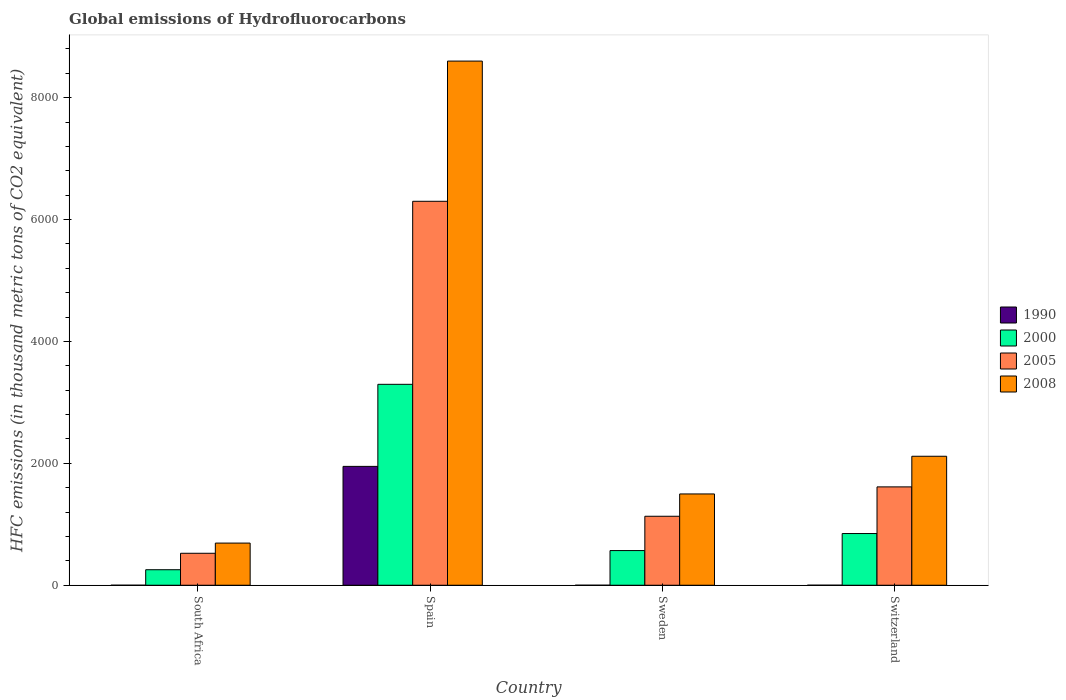Are the number of bars per tick equal to the number of legend labels?
Give a very brief answer. Yes. Are the number of bars on each tick of the X-axis equal?
Your answer should be compact. Yes. How many bars are there on the 1st tick from the left?
Your response must be concise. 4. How many bars are there on the 2nd tick from the right?
Provide a succinct answer. 4. What is the global emissions of Hydrofluorocarbons in 2008 in Sweden?
Give a very brief answer. 1498. Across all countries, what is the maximum global emissions of Hydrofluorocarbons in 1990?
Offer a terse response. 1950.3. Across all countries, what is the minimum global emissions of Hydrofluorocarbons in 2008?
Give a very brief answer. 691.6. In which country was the global emissions of Hydrofluorocarbons in 1990 minimum?
Provide a short and direct response. South Africa. What is the total global emissions of Hydrofluorocarbons in 2005 in the graph?
Offer a terse response. 9570.5. What is the difference between the global emissions of Hydrofluorocarbons in 2000 in South Africa and that in Spain?
Give a very brief answer. -3042.2. What is the difference between the global emissions of Hydrofluorocarbons in 1990 in South Africa and the global emissions of Hydrofluorocarbons in 2000 in Switzerland?
Offer a terse response. -848. What is the average global emissions of Hydrofluorocarbons in 2000 per country?
Offer a very short reply. 1242.1. What is the difference between the global emissions of Hydrofluorocarbons of/in 1990 and global emissions of Hydrofluorocarbons of/in 2008 in Switzerland?
Offer a terse response. -2116.1. What is the ratio of the global emissions of Hydrofluorocarbons in 2008 in South Africa to that in Spain?
Keep it short and to the point. 0.08. Is the global emissions of Hydrofluorocarbons in 1990 in South Africa less than that in Switzerland?
Your answer should be very brief. Yes. Is the difference between the global emissions of Hydrofluorocarbons in 1990 in South Africa and Switzerland greater than the difference between the global emissions of Hydrofluorocarbons in 2008 in South Africa and Switzerland?
Keep it short and to the point. Yes. What is the difference between the highest and the second highest global emissions of Hydrofluorocarbons in 2008?
Keep it short and to the point. 7102.9. What is the difference between the highest and the lowest global emissions of Hydrofluorocarbons in 2008?
Ensure brevity in your answer.  7909.3. What does the 3rd bar from the left in Switzerland represents?
Give a very brief answer. 2005. How many bars are there?
Ensure brevity in your answer.  16. How many countries are there in the graph?
Ensure brevity in your answer.  4. Are the values on the major ticks of Y-axis written in scientific E-notation?
Ensure brevity in your answer.  No. Where does the legend appear in the graph?
Make the answer very short. Center right. What is the title of the graph?
Make the answer very short. Global emissions of Hydrofluorocarbons. Does "1995" appear as one of the legend labels in the graph?
Make the answer very short. No. What is the label or title of the X-axis?
Keep it short and to the point. Country. What is the label or title of the Y-axis?
Your response must be concise. HFC emissions (in thousand metric tons of CO2 equivalent). What is the HFC emissions (in thousand metric tons of CO2 equivalent) of 2000 in South Africa?
Ensure brevity in your answer.  254.6. What is the HFC emissions (in thousand metric tons of CO2 equivalent) of 2005 in South Africa?
Your answer should be compact. 524.5. What is the HFC emissions (in thousand metric tons of CO2 equivalent) of 2008 in South Africa?
Your response must be concise. 691.6. What is the HFC emissions (in thousand metric tons of CO2 equivalent) in 1990 in Spain?
Your answer should be compact. 1950.3. What is the HFC emissions (in thousand metric tons of CO2 equivalent) in 2000 in Spain?
Your response must be concise. 3296.8. What is the HFC emissions (in thousand metric tons of CO2 equivalent) of 2005 in Spain?
Offer a terse response. 6300.3. What is the HFC emissions (in thousand metric tons of CO2 equivalent) in 2008 in Spain?
Make the answer very short. 8600.9. What is the HFC emissions (in thousand metric tons of CO2 equivalent) of 2000 in Sweden?
Ensure brevity in your answer.  568.8. What is the HFC emissions (in thousand metric tons of CO2 equivalent) of 2005 in Sweden?
Make the answer very short. 1131.9. What is the HFC emissions (in thousand metric tons of CO2 equivalent) in 2008 in Sweden?
Give a very brief answer. 1498. What is the HFC emissions (in thousand metric tons of CO2 equivalent) in 1990 in Switzerland?
Offer a very short reply. 0.3. What is the HFC emissions (in thousand metric tons of CO2 equivalent) in 2000 in Switzerland?
Provide a succinct answer. 848.2. What is the HFC emissions (in thousand metric tons of CO2 equivalent) in 2005 in Switzerland?
Provide a short and direct response. 1613.8. What is the HFC emissions (in thousand metric tons of CO2 equivalent) of 2008 in Switzerland?
Your answer should be compact. 2116.4. Across all countries, what is the maximum HFC emissions (in thousand metric tons of CO2 equivalent) in 1990?
Keep it short and to the point. 1950.3. Across all countries, what is the maximum HFC emissions (in thousand metric tons of CO2 equivalent) of 2000?
Offer a terse response. 3296.8. Across all countries, what is the maximum HFC emissions (in thousand metric tons of CO2 equivalent) in 2005?
Your response must be concise. 6300.3. Across all countries, what is the maximum HFC emissions (in thousand metric tons of CO2 equivalent) of 2008?
Your answer should be compact. 8600.9. Across all countries, what is the minimum HFC emissions (in thousand metric tons of CO2 equivalent) of 1990?
Your answer should be very brief. 0.2. Across all countries, what is the minimum HFC emissions (in thousand metric tons of CO2 equivalent) of 2000?
Make the answer very short. 254.6. Across all countries, what is the minimum HFC emissions (in thousand metric tons of CO2 equivalent) of 2005?
Keep it short and to the point. 524.5. Across all countries, what is the minimum HFC emissions (in thousand metric tons of CO2 equivalent) of 2008?
Your answer should be very brief. 691.6. What is the total HFC emissions (in thousand metric tons of CO2 equivalent) in 1990 in the graph?
Make the answer very short. 1951. What is the total HFC emissions (in thousand metric tons of CO2 equivalent) of 2000 in the graph?
Your response must be concise. 4968.4. What is the total HFC emissions (in thousand metric tons of CO2 equivalent) in 2005 in the graph?
Your answer should be compact. 9570.5. What is the total HFC emissions (in thousand metric tons of CO2 equivalent) in 2008 in the graph?
Your answer should be compact. 1.29e+04. What is the difference between the HFC emissions (in thousand metric tons of CO2 equivalent) in 1990 in South Africa and that in Spain?
Offer a terse response. -1950.1. What is the difference between the HFC emissions (in thousand metric tons of CO2 equivalent) of 2000 in South Africa and that in Spain?
Ensure brevity in your answer.  -3042.2. What is the difference between the HFC emissions (in thousand metric tons of CO2 equivalent) of 2005 in South Africa and that in Spain?
Your response must be concise. -5775.8. What is the difference between the HFC emissions (in thousand metric tons of CO2 equivalent) in 2008 in South Africa and that in Spain?
Your answer should be very brief. -7909.3. What is the difference between the HFC emissions (in thousand metric tons of CO2 equivalent) in 1990 in South Africa and that in Sweden?
Your response must be concise. 0. What is the difference between the HFC emissions (in thousand metric tons of CO2 equivalent) of 2000 in South Africa and that in Sweden?
Provide a short and direct response. -314.2. What is the difference between the HFC emissions (in thousand metric tons of CO2 equivalent) of 2005 in South Africa and that in Sweden?
Offer a terse response. -607.4. What is the difference between the HFC emissions (in thousand metric tons of CO2 equivalent) in 2008 in South Africa and that in Sweden?
Your answer should be compact. -806.4. What is the difference between the HFC emissions (in thousand metric tons of CO2 equivalent) in 2000 in South Africa and that in Switzerland?
Your response must be concise. -593.6. What is the difference between the HFC emissions (in thousand metric tons of CO2 equivalent) of 2005 in South Africa and that in Switzerland?
Provide a succinct answer. -1089.3. What is the difference between the HFC emissions (in thousand metric tons of CO2 equivalent) in 2008 in South Africa and that in Switzerland?
Your answer should be very brief. -1424.8. What is the difference between the HFC emissions (in thousand metric tons of CO2 equivalent) of 1990 in Spain and that in Sweden?
Make the answer very short. 1950.1. What is the difference between the HFC emissions (in thousand metric tons of CO2 equivalent) in 2000 in Spain and that in Sweden?
Offer a terse response. 2728. What is the difference between the HFC emissions (in thousand metric tons of CO2 equivalent) of 2005 in Spain and that in Sweden?
Give a very brief answer. 5168.4. What is the difference between the HFC emissions (in thousand metric tons of CO2 equivalent) of 2008 in Spain and that in Sweden?
Provide a succinct answer. 7102.9. What is the difference between the HFC emissions (in thousand metric tons of CO2 equivalent) in 1990 in Spain and that in Switzerland?
Make the answer very short. 1950. What is the difference between the HFC emissions (in thousand metric tons of CO2 equivalent) in 2000 in Spain and that in Switzerland?
Your answer should be very brief. 2448.6. What is the difference between the HFC emissions (in thousand metric tons of CO2 equivalent) of 2005 in Spain and that in Switzerland?
Provide a succinct answer. 4686.5. What is the difference between the HFC emissions (in thousand metric tons of CO2 equivalent) in 2008 in Spain and that in Switzerland?
Your answer should be very brief. 6484.5. What is the difference between the HFC emissions (in thousand metric tons of CO2 equivalent) of 2000 in Sweden and that in Switzerland?
Make the answer very short. -279.4. What is the difference between the HFC emissions (in thousand metric tons of CO2 equivalent) in 2005 in Sweden and that in Switzerland?
Provide a succinct answer. -481.9. What is the difference between the HFC emissions (in thousand metric tons of CO2 equivalent) of 2008 in Sweden and that in Switzerland?
Keep it short and to the point. -618.4. What is the difference between the HFC emissions (in thousand metric tons of CO2 equivalent) of 1990 in South Africa and the HFC emissions (in thousand metric tons of CO2 equivalent) of 2000 in Spain?
Your answer should be very brief. -3296.6. What is the difference between the HFC emissions (in thousand metric tons of CO2 equivalent) of 1990 in South Africa and the HFC emissions (in thousand metric tons of CO2 equivalent) of 2005 in Spain?
Offer a terse response. -6300.1. What is the difference between the HFC emissions (in thousand metric tons of CO2 equivalent) in 1990 in South Africa and the HFC emissions (in thousand metric tons of CO2 equivalent) in 2008 in Spain?
Your answer should be very brief. -8600.7. What is the difference between the HFC emissions (in thousand metric tons of CO2 equivalent) of 2000 in South Africa and the HFC emissions (in thousand metric tons of CO2 equivalent) of 2005 in Spain?
Your answer should be compact. -6045.7. What is the difference between the HFC emissions (in thousand metric tons of CO2 equivalent) of 2000 in South Africa and the HFC emissions (in thousand metric tons of CO2 equivalent) of 2008 in Spain?
Your answer should be very brief. -8346.3. What is the difference between the HFC emissions (in thousand metric tons of CO2 equivalent) in 2005 in South Africa and the HFC emissions (in thousand metric tons of CO2 equivalent) in 2008 in Spain?
Your answer should be compact. -8076.4. What is the difference between the HFC emissions (in thousand metric tons of CO2 equivalent) of 1990 in South Africa and the HFC emissions (in thousand metric tons of CO2 equivalent) of 2000 in Sweden?
Provide a short and direct response. -568.6. What is the difference between the HFC emissions (in thousand metric tons of CO2 equivalent) of 1990 in South Africa and the HFC emissions (in thousand metric tons of CO2 equivalent) of 2005 in Sweden?
Make the answer very short. -1131.7. What is the difference between the HFC emissions (in thousand metric tons of CO2 equivalent) of 1990 in South Africa and the HFC emissions (in thousand metric tons of CO2 equivalent) of 2008 in Sweden?
Offer a very short reply. -1497.8. What is the difference between the HFC emissions (in thousand metric tons of CO2 equivalent) of 2000 in South Africa and the HFC emissions (in thousand metric tons of CO2 equivalent) of 2005 in Sweden?
Provide a short and direct response. -877.3. What is the difference between the HFC emissions (in thousand metric tons of CO2 equivalent) in 2000 in South Africa and the HFC emissions (in thousand metric tons of CO2 equivalent) in 2008 in Sweden?
Make the answer very short. -1243.4. What is the difference between the HFC emissions (in thousand metric tons of CO2 equivalent) in 2005 in South Africa and the HFC emissions (in thousand metric tons of CO2 equivalent) in 2008 in Sweden?
Make the answer very short. -973.5. What is the difference between the HFC emissions (in thousand metric tons of CO2 equivalent) in 1990 in South Africa and the HFC emissions (in thousand metric tons of CO2 equivalent) in 2000 in Switzerland?
Give a very brief answer. -848. What is the difference between the HFC emissions (in thousand metric tons of CO2 equivalent) of 1990 in South Africa and the HFC emissions (in thousand metric tons of CO2 equivalent) of 2005 in Switzerland?
Your response must be concise. -1613.6. What is the difference between the HFC emissions (in thousand metric tons of CO2 equivalent) of 1990 in South Africa and the HFC emissions (in thousand metric tons of CO2 equivalent) of 2008 in Switzerland?
Provide a short and direct response. -2116.2. What is the difference between the HFC emissions (in thousand metric tons of CO2 equivalent) of 2000 in South Africa and the HFC emissions (in thousand metric tons of CO2 equivalent) of 2005 in Switzerland?
Your answer should be very brief. -1359.2. What is the difference between the HFC emissions (in thousand metric tons of CO2 equivalent) in 2000 in South Africa and the HFC emissions (in thousand metric tons of CO2 equivalent) in 2008 in Switzerland?
Your response must be concise. -1861.8. What is the difference between the HFC emissions (in thousand metric tons of CO2 equivalent) of 2005 in South Africa and the HFC emissions (in thousand metric tons of CO2 equivalent) of 2008 in Switzerland?
Your answer should be compact. -1591.9. What is the difference between the HFC emissions (in thousand metric tons of CO2 equivalent) of 1990 in Spain and the HFC emissions (in thousand metric tons of CO2 equivalent) of 2000 in Sweden?
Keep it short and to the point. 1381.5. What is the difference between the HFC emissions (in thousand metric tons of CO2 equivalent) in 1990 in Spain and the HFC emissions (in thousand metric tons of CO2 equivalent) in 2005 in Sweden?
Provide a succinct answer. 818.4. What is the difference between the HFC emissions (in thousand metric tons of CO2 equivalent) in 1990 in Spain and the HFC emissions (in thousand metric tons of CO2 equivalent) in 2008 in Sweden?
Make the answer very short. 452.3. What is the difference between the HFC emissions (in thousand metric tons of CO2 equivalent) in 2000 in Spain and the HFC emissions (in thousand metric tons of CO2 equivalent) in 2005 in Sweden?
Provide a succinct answer. 2164.9. What is the difference between the HFC emissions (in thousand metric tons of CO2 equivalent) in 2000 in Spain and the HFC emissions (in thousand metric tons of CO2 equivalent) in 2008 in Sweden?
Keep it short and to the point. 1798.8. What is the difference between the HFC emissions (in thousand metric tons of CO2 equivalent) in 2005 in Spain and the HFC emissions (in thousand metric tons of CO2 equivalent) in 2008 in Sweden?
Your answer should be very brief. 4802.3. What is the difference between the HFC emissions (in thousand metric tons of CO2 equivalent) in 1990 in Spain and the HFC emissions (in thousand metric tons of CO2 equivalent) in 2000 in Switzerland?
Offer a very short reply. 1102.1. What is the difference between the HFC emissions (in thousand metric tons of CO2 equivalent) of 1990 in Spain and the HFC emissions (in thousand metric tons of CO2 equivalent) of 2005 in Switzerland?
Your response must be concise. 336.5. What is the difference between the HFC emissions (in thousand metric tons of CO2 equivalent) in 1990 in Spain and the HFC emissions (in thousand metric tons of CO2 equivalent) in 2008 in Switzerland?
Ensure brevity in your answer.  -166.1. What is the difference between the HFC emissions (in thousand metric tons of CO2 equivalent) of 2000 in Spain and the HFC emissions (in thousand metric tons of CO2 equivalent) of 2005 in Switzerland?
Offer a very short reply. 1683. What is the difference between the HFC emissions (in thousand metric tons of CO2 equivalent) in 2000 in Spain and the HFC emissions (in thousand metric tons of CO2 equivalent) in 2008 in Switzerland?
Keep it short and to the point. 1180.4. What is the difference between the HFC emissions (in thousand metric tons of CO2 equivalent) in 2005 in Spain and the HFC emissions (in thousand metric tons of CO2 equivalent) in 2008 in Switzerland?
Keep it short and to the point. 4183.9. What is the difference between the HFC emissions (in thousand metric tons of CO2 equivalent) in 1990 in Sweden and the HFC emissions (in thousand metric tons of CO2 equivalent) in 2000 in Switzerland?
Give a very brief answer. -848. What is the difference between the HFC emissions (in thousand metric tons of CO2 equivalent) in 1990 in Sweden and the HFC emissions (in thousand metric tons of CO2 equivalent) in 2005 in Switzerland?
Offer a terse response. -1613.6. What is the difference between the HFC emissions (in thousand metric tons of CO2 equivalent) of 1990 in Sweden and the HFC emissions (in thousand metric tons of CO2 equivalent) of 2008 in Switzerland?
Your response must be concise. -2116.2. What is the difference between the HFC emissions (in thousand metric tons of CO2 equivalent) in 2000 in Sweden and the HFC emissions (in thousand metric tons of CO2 equivalent) in 2005 in Switzerland?
Make the answer very short. -1045. What is the difference between the HFC emissions (in thousand metric tons of CO2 equivalent) in 2000 in Sweden and the HFC emissions (in thousand metric tons of CO2 equivalent) in 2008 in Switzerland?
Offer a terse response. -1547.6. What is the difference between the HFC emissions (in thousand metric tons of CO2 equivalent) of 2005 in Sweden and the HFC emissions (in thousand metric tons of CO2 equivalent) of 2008 in Switzerland?
Make the answer very short. -984.5. What is the average HFC emissions (in thousand metric tons of CO2 equivalent) in 1990 per country?
Ensure brevity in your answer.  487.75. What is the average HFC emissions (in thousand metric tons of CO2 equivalent) in 2000 per country?
Your response must be concise. 1242.1. What is the average HFC emissions (in thousand metric tons of CO2 equivalent) in 2005 per country?
Provide a succinct answer. 2392.62. What is the average HFC emissions (in thousand metric tons of CO2 equivalent) in 2008 per country?
Keep it short and to the point. 3226.72. What is the difference between the HFC emissions (in thousand metric tons of CO2 equivalent) in 1990 and HFC emissions (in thousand metric tons of CO2 equivalent) in 2000 in South Africa?
Offer a very short reply. -254.4. What is the difference between the HFC emissions (in thousand metric tons of CO2 equivalent) of 1990 and HFC emissions (in thousand metric tons of CO2 equivalent) of 2005 in South Africa?
Provide a succinct answer. -524.3. What is the difference between the HFC emissions (in thousand metric tons of CO2 equivalent) of 1990 and HFC emissions (in thousand metric tons of CO2 equivalent) of 2008 in South Africa?
Give a very brief answer. -691.4. What is the difference between the HFC emissions (in thousand metric tons of CO2 equivalent) in 2000 and HFC emissions (in thousand metric tons of CO2 equivalent) in 2005 in South Africa?
Provide a short and direct response. -269.9. What is the difference between the HFC emissions (in thousand metric tons of CO2 equivalent) in 2000 and HFC emissions (in thousand metric tons of CO2 equivalent) in 2008 in South Africa?
Your answer should be very brief. -437. What is the difference between the HFC emissions (in thousand metric tons of CO2 equivalent) in 2005 and HFC emissions (in thousand metric tons of CO2 equivalent) in 2008 in South Africa?
Ensure brevity in your answer.  -167.1. What is the difference between the HFC emissions (in thousand metric tons of CO2 equivalent) in 1990 and HFC emissions (in thousand metric tons of CO2 equivalent) in 2000 in Spain?
Provide a succinct answer. -1346.5. What is the difference between the HFC emissions (in thousand metric tons of CO2 equivalent) in 1990 and HFC emissions (in thousand metric tons of CO2 equivalent) in 2005 in Spain?
Give a very brief answer. -4350. What is the difference between the HFC emissions (in thousand metric tons of CO2 equivalent) in 1990 and HFC emissions (in thousand metric tons of CO2 equivalent) in 2008 in Spain?
Give a very brief answer. -6650.6. What is the difference between the HFC emissions (in thousand metric tons of CO2 equivalent) in 2000 and HFC emissions (in thousand metric tons of CO2 equivalent) in 2005 in Spain?
Your response must be concise. -3003.5. What is the difference between the HFC emissions (in thousand metric tons of CO2 equivalent) in 2000 and HFC emissions (in thousand metric tons of CO2 equivalent) in 2008 in Spain?
Your response must be concise. -5304.1. What is the difference between the HFC emissions (in thousand metric tons of CO2 equivalent) of 2005 and HFC emissions (in thousand metric tons of CO2 equivalent) of 2008 in Spain?
Your answer should be compact. -2300.6. What is the difference between the HFC emissions (in thousand metric tons of CO2 equivalent) in 1990 and HFC emissions (in thousand metric tons of CO2 equivalent) in 2000 in Sweden?
Give a very brief answer. -568.6. What is the difference between the HFC emissions (in thousand metric tons of CO2 equivalent) of 1990 and HFC emissions (in thousand metric tons of CO2 equivalent) of 2005 in Sweden?
Offer a terse response. -1131.7. What is the difference between the HFC emissions (in thousand metric tons of CO2 equivalent) of 1990 and HFC emissions (in thousand metric tons of CO2 equivalent) of 2008 in Sweden?
Your answer should be very brief. -1497.8. What is the difference between the HFC emissions (in thousand metric tons of CO2 equivalent) in 2000 and HFC emissions (in thousand metric tons of CO2 equivalent) in 2005 in Sweden?
Your answer should be very brief. -563.1. What is the difference between the HFC emissions (in thousand metric tons of CO2 equivalent) in 2000 and HFC emissions (in thousand metric tons of CO2 equivalent) in 2008 in Sweden?
Offer a very short reply. -929.2. What is the difference between the HFC emissions (in thousand metric tons of CO2 equivalent) of 2005 and HFC emissions (in thousand metric tons of CO2 equivalent) of 2008 in Sweden?
Ensure brevity in your answer.  -366.1. What is the difference between the HFC emissions (in thousand metric tons of CO2 equivalent) of 1990 and HFC emissions (in thousand metric tons of CO2 equivalent) of 2000 in Switzerland?
Your response must be concise. -847.9. What is the difference between the HFC emissions (in thousand metric tons of CO2 equivalent) in 1990 and HFC emissions (in thousand metric tons of CO2 equivalent) in 2005 in Switzerland?
Provide a succinct answer. -1613.5. What is the difference between the HFC emissions (in thousand metric tons of CO2 equivalent) of 1990 and HFC emissions (in thousand metric tons of CO2 equivalent) of 2008 in Switzerland?
Make the answer very short. -2116.1. What is the difference between the HFC emissions (in thousand metric tons of CO2 equivalent) of 2000 and HFC emissions (in thousand metric tons of CO2 equivalent) of 2005 in Switzerland?
Your answer should be very brief. -765.6. What is the difference between the HFC emissions (in thousand metric tons of CO2 equivalent) of 2000 and HFC emissions (in thousand metric tons of CO2 equivalent) of 2008 in Switzerland?
Keep it short and to the point. -1268.2. What is the difference between the HFC emissions (in thousand metric tons of CO2 equivalent) of 2005 and HFC emissions (in thousand metric tons of CO2 equivalent) of 2008 in Switzerland?
Give a very brief answer. -502.6. What is the ratio of the HFC emissions (in thousand metric tons of CO2 equivalent) of 1990 in South Africa to that in Spain?
Ensure brevity in your answer.  0. What is the ratio of the HFC emissions (in thousand metric tons of CO2 equivalent) in 2000 in South Africa to that in Spain?
Offer a terse response. 0.08. What is the ratio of the HFC emissions (in thousand metric tons of CO2 equivalent) of 2005 in South Africa to that in Spain?
Offer a very short reply. 0.08. What is the ratio of the HFC emissions (in thousand metric tons of CO2 equivalent) in 2008 in South Africa to that in Spain?
Offer a terse response. 0.08. What is the ratio of the HFC emissions (in thousand metric tons of CO2 equivalent) in 1990 in South Africa to that in Sweden?
Give a very brief answer. 1. What is the ratio of the HFC emissions (in thousand metric tons of CO2 equivalent) in 2000 in South Africa to that in Sweden?
Your answer should be very brief. 0.45. What is the ratio of the HFC emissions (in thousand metric tons of CO2 equivalent) in 2005 in South Africa to that in Sweden?
Provide a short and direct response. 0.46. What is the ratio of the HFC emissions (in thousand metric tons of CO2 equivalent) in 2008 in South Africa to that in Sweden?
Offer a very short reply. 0.46. What is the ratio of the HFC emissions (in thousand metric tons of CO2 equivalent) in 2000 in South Africa to that in Switzerland?
Your answer should be compact. 0.3. What is the ratio of the HFC emissions (in thousand metric tons of CO2 equivalent) of 2005 in South Africa to that in Switzerland?
Your answer should be compact. 0.33. What is the ratio of the HFC emissions (in thousand metric tons of CO2 equivalent) of 2008 in South Africa to that in Switzerland?
Your answer should be compact. 0.33. What is the ratio of the HFC emissions (in thousand metric tons of CO2 equivalent) in 1990 in Spain to that in Sweden?
Offer a very short reply. 9751.5. What is the ratio of the HFC emissions (in thousand metric tons of CO2 equivalent) of 2000 in Spain to that in Sweden?
Your answer should be very brief. 5.8. What is the ratio of the HFC emissions (in thousand metric tons of CO2 equivalent) in 2005 in Spain to that in Sweden?
Keep it short and to the point. 5.57. What is the ratio of the HFC emissions (in thousand metric tons of CO2 equivalent) in 2008 in Spain to that in Sweden?
Make the answer very short. 5.74. What is the ratio of the HFC emissions (in thousand metric tons of CO2 equivalent) in 1990 in Spain to that in Switzerland?
Ensure brevity in your answer.  6501. What is the ratio of the HFC emissions (in thousand metric tons of CO2 equivalent) in 2000 in Spain to that in Switzerland?
Make the answer very short. 3.89. What is the ratio of the HFC emissions (in thousand metric tons of CO2 equivalent) of 2005 in Spain to that in Switzerland?
Your answer should be very brief. 3.9. What is the ratio of the HFC emissions (in thousand metric tons of CO2 equivalent) of 2008 in Spain to that in Switzerland?
Provide a short and direct response. 4.06. What is the ratio of the HFC emissions (in thousand metric tons of CO2 equivalent) in 1990 in Sweden to that in Switzerland?
Your answer should be compact. 0.67. What is the ratio of the HFC emissions (in thousand metric tons of CO2 equivalent) of 2000 in Sweden to that in Switzerland?
Your answer should be very brief. 0.67. What is the ratio of the HFC emissions (in thousand metric tons of CO2 equivalent) in 2005 in Sweden to that in Switzerland?
Make the answer very short. 0.7. What is the ratio of the HFC emissions (in thousand metric tons of CO2 equivalent) of 2008 in Sweden to that in Switzerland?
Make the answer very short. 0.71. What is the difference between the highest and the second highest HFC emissions (in thousand metric tons of CO2 equivalent) of 1990?
Give a very brief answer. 1950. What is the difference between the highest and the second highest HFC emissions (in thousand metric tons of CO2 equivalent) in 2000?
Give a very brief answer. 2448.6. What is the difference between the highest and the second highest HFC emissions (in thousand metric tons of CO2 equivalent) in 2005?
Ensure brevity in your answer.  4686.5. What is the difference between the highest and the second highest HFC emissions (in thousand metric tons of CO2 equivalent) of 2008?
Give a very brief answer. 6484.5. What is the difference between the highest and the lowest HFC emissions (in thousand metric tons of CO2 equivalent) of 1990?
Keep it short and to the point. 1950.1. What is the difference between the highest and the lowest HFC emissions (in thousand metric tons of CO2 equivalent) in 2000?
Make the answer very short. 3042.2. What is the difference between the highest and the lowest HFC emissions (in thousand metric tons of CO2 equivalent) of 2005?
Offer a terse response. 5775.8. What is the difference between the highest and the lowest HFC emissions (in thousand metric tons of CO2 equivalent) of 2008?
Provide a succinct answer. 7909.3. 